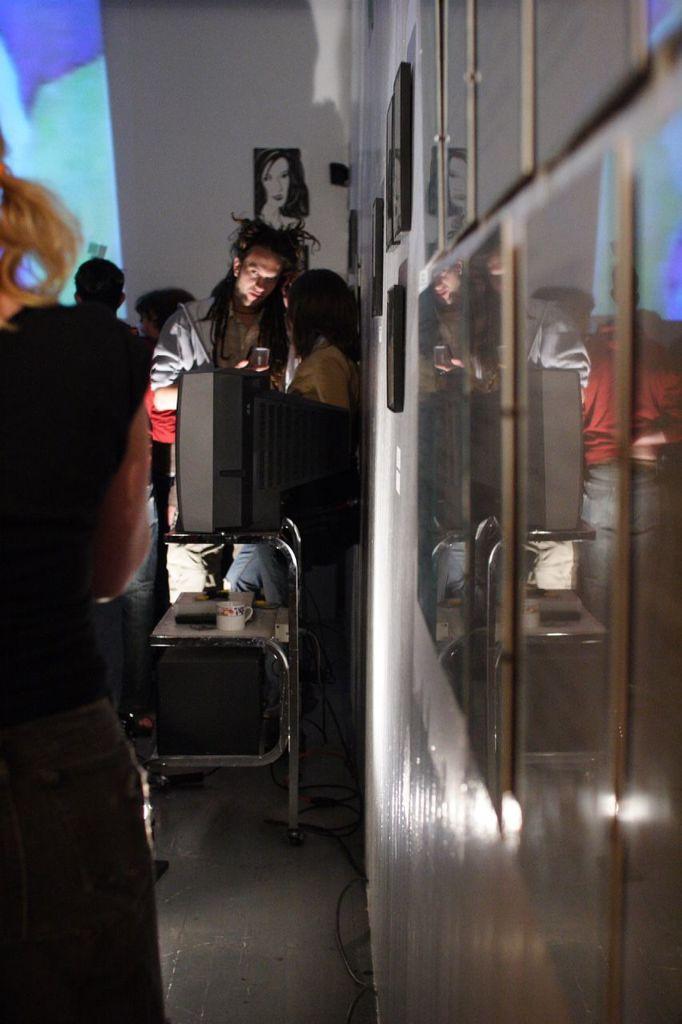Describe this image in one or two sentences. In this image, we can see few people. Here there is a stand. Television, some items are placed on it. Rights side of the image, we can see a wall with photo frames. Background we can see some poster. 